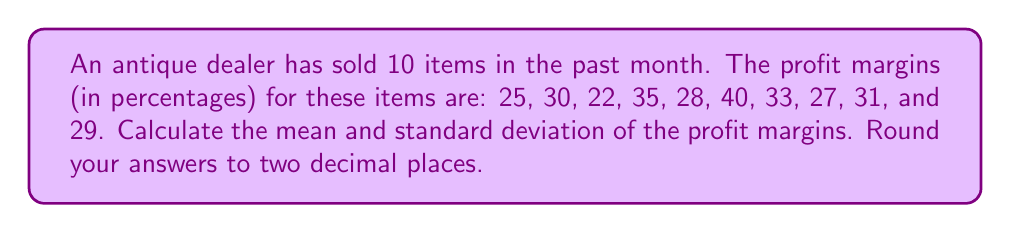Can you solve this math problem? To solve this problem, we need to calculate the mean and standard deviation of the profit margins.

1. Calculate the mean:
   The mean is the sum of all values divided by the number of values.
   
   $$ \text{Mean} = \frac{\sum_{i=1}^{n} x_i}{n} $$
   
   where $x_i$ are the individual profit margins and $n$ is the number of items.
   
   $$ \text{Mean} = \frac{25 + 30 + 22 + 35 + 28 + 40 + 33 + 27 + 31 + 29}{10} = \frac{300}{10} = 30 $$

2. Calculate the standard deviation:
   The standard deviation is the square root of the variance, which is the average of the squared differences from the mean.
   
   $$ s = \sqrt{\frac{\sum_{i=1}^{n} (x_i - \bar{x})^2}{n-1}} $$
   
   where $s$ is the standard deviation, $x_i$ are the individual profit margins, $\bar{x}$ is the mean, and $n$ is the number of items.

   First, calculate the squared differences from the mean:
   $$(25-30)^2 = 25, (30-30)^2 = 0, (22-30)^2 = 64, (35-30)^2 = 25, (28-30)^2 = 4,$$
   $$(40-30)^2 = 100, (33-30)^2 = 9, (27-30)^2 = 9, (31-30)^2 = 1, (29-30)^2 = 1$$

   Sum these squared differences:
   $$25 + 0 + 64 + 25 + 4 + 100 + 9 + 9 + 1 + 1 = 238$$

   Divide by $(n-1) = 9$ and take the square root:
   $$ s = \sqrt{\frac{238}{9}} \approx 5.14 $$

Rounding to two decimal places:
Mean = 30.00
Standard deviation = 5.14
Answer: Mean: 30.00%, Standard deviation: 5.14% 